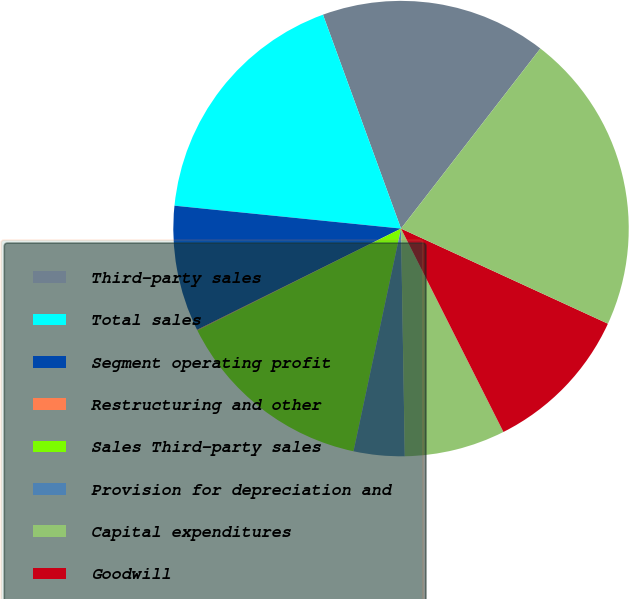Convert chart to OTSL. <chart><loc_0><loc_0><loc_500><loc_500><pie_chart><fcel>Third-party sales<fcel>Total sales<fcel>Segment operating profit<fcel>Restructuring and other<fcel>Sales Third-party sales<fcel>Provision for depreciation and<fcel>Capital expenditures<fcel>Goodwill<fcel>Total assets 2017<nl><fcel>16.05%<fcel>17.83%<fcel>8.94%<fcel>0.05%<fcel>14.27%<fcel>3.61%<fcel>7.16%<fcel>10.72%<fcel>21.38%<nl></chart> 